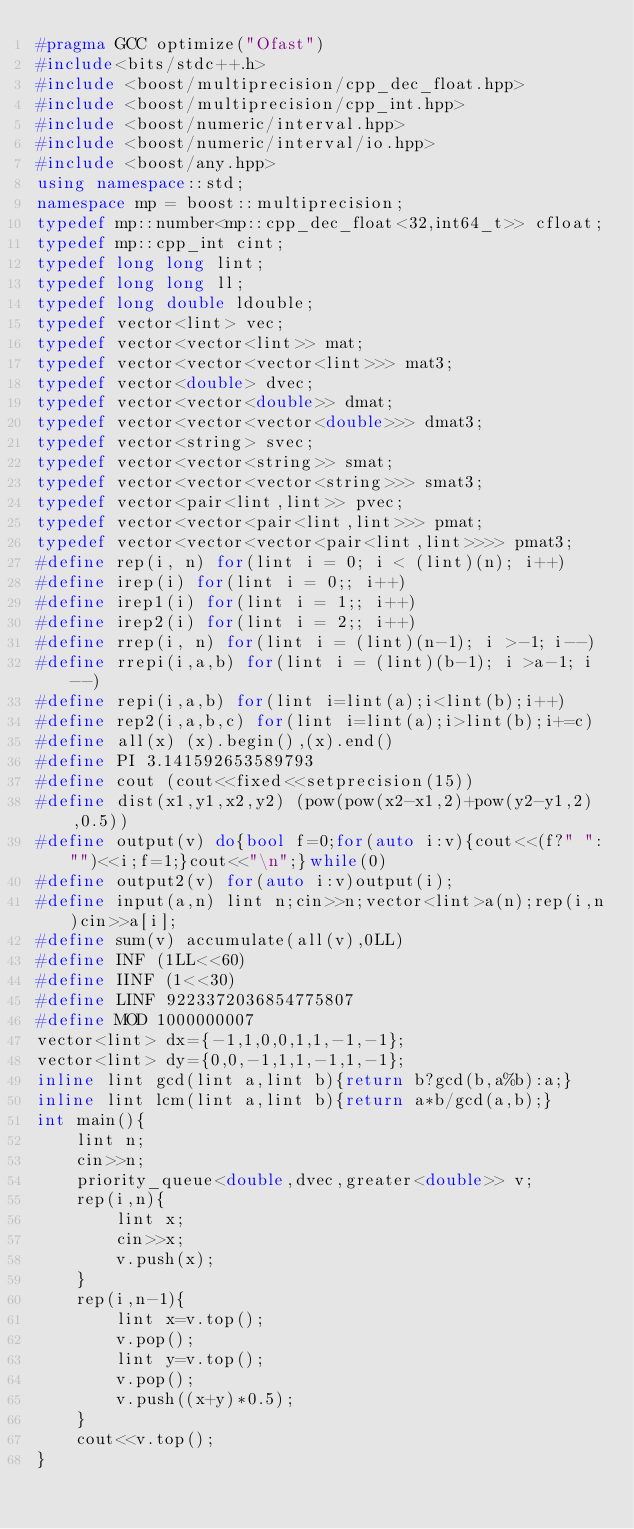<code> <loc_0><loc_0><loc_500><loc_500><_C++_>#pragma GCC optimize("Ofast")
#include<bits/stdc++.h>
#include <boost/multiprecision/cpp_dec_float.hpp>
#include <boost/multiprecision/cpp_int.hpp>
#include <boost/numeric/interval.hpp>
#include <boost/numeric/interval/io.hpp>
#include <boost/any.hpp>
using namespace::std;
namespace mp = boost::multiprecision;
typedef mp::number<mp::cpp_dec_float<32,int64_t>> cfloat;
typedef mp::cpp_int cint;
typedef long long lint;
typedef long long ll;
typedef long double ldouble;
typedef vector<lint> vec;
typedef vector<vector<lint>> mat;
typedef vector<vector<vector<lint>>> mat3;
typedef vector<double> dvec;
typedef vector<vector<double>> dmat;
typedef vector<vector<vector<double>>> dmat3;
typedef vector<string> svec;
typedef vector<vector<string>> smat;
typedef vector<vector<vector<string>>> smat3;
typedef vector<pair<lint,lint>> pvec;
typedef vector<vector<pair<lint,lint>>> pmat;
typedef vector<vector<vector<pair<lint,lint>>>> pmat3;
#define rep(i, n) for(lint i = 0; i < (lint)(n); i++)
#define irep(i) for(lint i = 0;; i++)
#define irep1(i) for(lint i = 1;; i++)
#define irep2(i) for(lint i = 2;; i++)
#define rrep(i, n) for(lint i = (lint)(n-1); i >-1; i--)
#define rrepi(i,a,b) for(lint i = (lint)(b-1); i >a-1; i--)
#define repi(i,a,b) for(lint i=lint(a);i<lint(b);i++)
#define rep2(i,a,b,c) for(lint i=lint(a);i>lint(b);i+=c)
#define all(x) (x).begin(),(x).end()
#define PI 3.141592653589793
#define cout (cout<<fixed<<setprecision(15))
#define dist(x1,y1,x2,y2) (pow(pow(x2-x1,2)+pow(y2-y1,2),0.5))
#define output(v) do{bool f=0;for(auto i:v){cout<<(f?" ":"")<<i;f=1;}cout<<"\n";}while(0)
#define output2(v) for(auto i:v)output(i);
#define input(a,n) lint n;cin>>n;vector<lint>a(n);rep(i,n)cin>>a[i];
#define sum(v) accumulate(all(v),0LL)
#define INF (1LL<<60)
#define IINF (1<<30)
#define LINF 9223372036854775807
#define MOD 1000000007
vector<lint> dx={-1,1,0,0,1,1,-1,-1};
vector<lint> dy={0,0,-1,1,1,-1,1,-1};
inline lint gcd(lint a,lint b){return b?gcd(b,a%b):a;}
inline lint lcm(lint a,lint b){return a*b/gcd(a,b);}
int main(){
    lint n;
    cin>>n;
    priority_queue<double,dvec,greater<double>> v;
    rep(i,n){
        lint x;
        cin>>x;
        v.push(x);
    }
    rep(i,n-1){
        lint x=v.top();
        v.pop();
        lint y=v.top();
        v.pop();
        v.push((x+y)*0.5);
    }
    cout<<v.top();
}</code> 